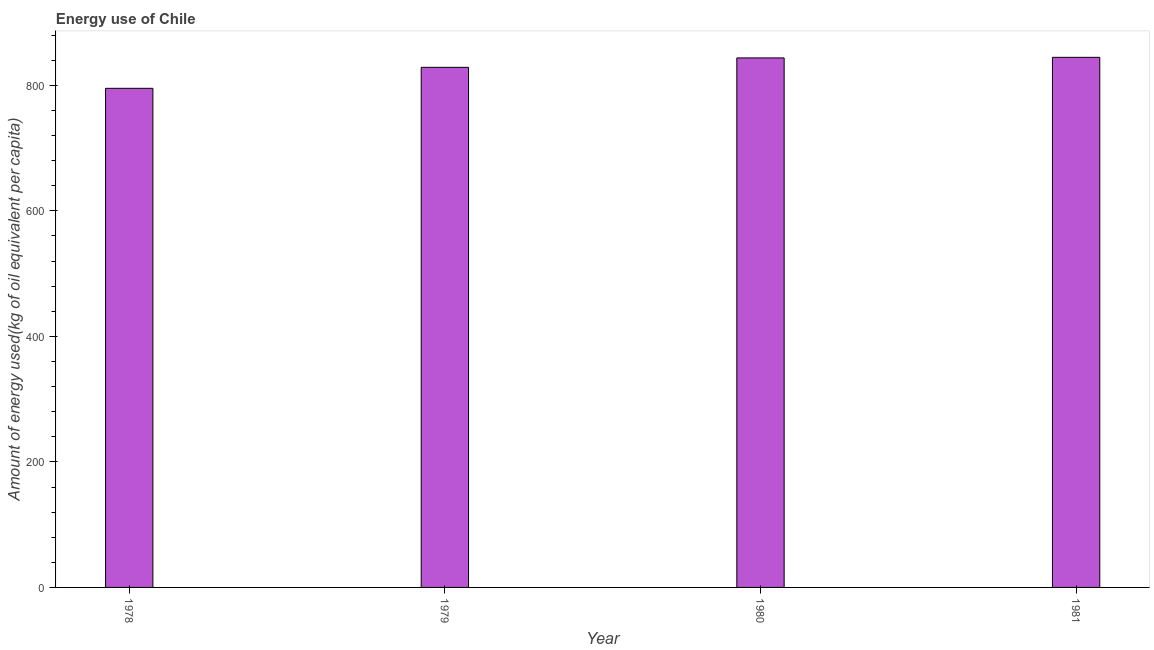What is the title of the graph?
Provide a succinct answer. Energy use of Chile. What is the label or title of the Y-axis?
Provide a succinct answer. Amount of energy used(kg of oil equivalent per capita). What is the amount of energy used in 1980?
Offer a terse response. 843.7. Across all years, what is the maximum amount of energy used?
Offer a very short reply. 844.62. Across all years, what is the minimum amount of energy used?
Your answer should be compact. 795.23. In which year was the amount of energy used minimum?
Your response must be concise. 1978. What is the sum of the amount of energy used?
Your answer should be very brief. 3312.21. What is the difference between the amount of energy used in 1978 and 1980?
Keep it short and to the point. -48.47. What is the average amount of energy used per year?
Make the answer very short. 828.05. What is the median amount of energy used?
Your response must be concise. 836.18. In how many years, is the amount of energy used greater than 280 kg?
Your answer should be very brief. 4. What is the ratio of the amount of energy used in 1979 to that in 1980?
Give a very brief answer. 0.98. What is the difference between the highest and the lowest amount of energy used?
Ensure brevity in your answer.  49.39. How many bars are there?
Your answer should be compact. 4. Are all the bars in the graph horizontal?
Offer a very short reply. No. What is the Amount of energy used(kg of oil equivalent per capita) of 1978?
Provide a succinct answer. 795.23. What is the Amount of energy used(kg of oil equivalent per capita) in 1979?
Provide a succinct answer. 828.66. What is the Amount of energy used(kg of oil equivalent per capita) in 1980?
Offer a terse response. 843.7. What is the Amount of energy used(kg of oil equivalent per capita) of 1981?
Ensure brevity in your answer.  844.62. What is the difference between the Amount of energy used(kg of oil equivalent per capita) in 1978 and 1979?
Provide a short and direct response. -33.44. What is the difference between the Amount of energy used(kg of oil equivalent per capita) in 1978 and 1980?
Keep it short and to the point. -48.47. What is the difference between the Amount of energy used(kg of oil equivalent per capita) in 1978 and 1981?
Your answer should be compact. -49.39. What is the difference between the Amount of energy used(kg of oil equivalent per capita) in 1979 and 1980?
Provide a short and direct response. -15.03. What is the difference between the Amount of energy used(kg of oil equivalent per capita) in 1979 and 1981?
Make the answer very short. -15.95. What is the difference between the Amount of energy used(kg of oil equivalent per capita) in 1980 and 1981?
Your response must be concise. -0.92. What is the ratio of the Amount of energy used(kg of oil equivalent per capita) in 1978 to that in 1979?
Provide a short and direct response. 0.96. What is the ratio of the Amount of energy used(kg of oil equivalent per capita) in 1978 to that in 1980?
Give a very brief answer. 0.94. What is the ratio of the Amount of energy used(kg of oil equivalent per capita) in 1978 to that in 1981?
Give a very brief answer. 0.94. What is the ratio of the Amount of energy used(kg of oil equivalent per capita) in 1979 to that in 1980?
Your response must be concise. 0.98. What is the ratio of the Amount of energy used(kg of oil equivalent per capita) in 1979 to that in 1981?
Ensure brevity in your answer.  0.98. What is the ratio of the Amount of energy used(kg of oil equivalent per capita) in 1980 to that in 1981?
Offer a very short reply. 1. 